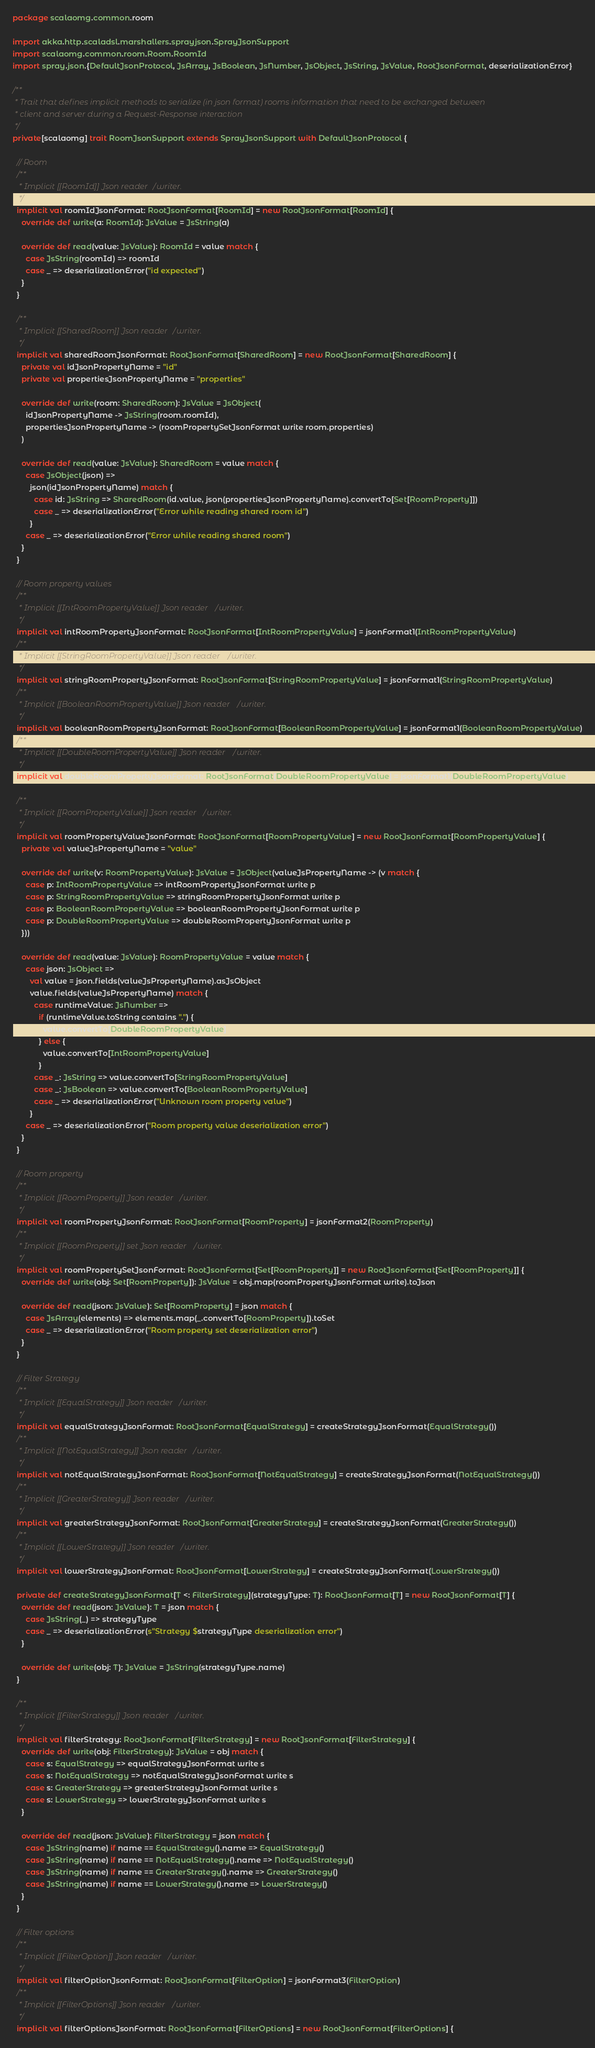Convert code to text. <code><loc_0><loc_0><loc_500><loc_500><_Scala_>package scalaomg.common.room

import akka.http.scaladsl.marshallers.sprayjson.SprayJsonSupport
import scalaomg.common.room.Room.RoomId
import spray.json.{DefaultJsonProtocol, JsArray, JsBoolean, JsNumber, JsObject, JsString, JsValue, RootJsonFormat, deserializationError}

/**
 * Trait that defines implicit methods to serialize (in json format) rooms information that need to be exchanged between
 * client and server during a Request-Response interaction
 */
private[scalaomg] trait RoomJsonSupport extends SprayJsonSupport with DefaultJsonProtocol {

  // Room
  /**
   * Implicit [[RoomId]] Json reader/writer.
   */
  implicit val roomIdJsonFormat: RootJsonFormat[RoomId] = new RootJsonFormat[RoomId] {
    override def write(a: RoomId): JsValue = JsString(a)

    override def read(value: JsValue): RoomId = value match {
      case JsString(roomId) => roomId
      case _ => deserializationError("id expected")
    }
  }

  /**
   * Implicit [[SharedRoom]] Json reader/writer.
   */
  implicit val sharedRoomJsonFormat: RootJsonFormat[SharedRoom] = new RootJsonFormat[SharedRoom] {
    private val idJsonPropertyName = "id"
    private val propertiesJsonPropertyName = "properties"

    override def write(room: SharedRoom): JsValue = JsObject(
      idJsonPropertyName -> JsString(room.roomId),
      propertiesJsonPropertyName -> (roomPropertySetJsonFormat write room.properties)
    )

    override def read(value: JsValue): SharedRoom = value match {
      case JsObject(json) =>
        json(idJsonPropertyName) match {
          case id: JsString => SharedRoom(id.value, json(propertiesJsonPropertyName).convertTo[Set[RoomProperty]])
          case _ => deserializationError("Error while reading shared room id")
        }
      case _ => deserializationError("Error while reading shared room")
    }
  }

  // Room property values
  /**
   * Implicit [[IntRoomPropertyValue]] Json reader/writer.
   */
  implicit val intRoomPropertyJsonFormat: RootJsonFormat[IntRoomPropertyValue] = jsonFormat1(IntRoomPropertyValue)
  /**
   * Implicit [[StringRoomPropertyValue]] Json reader/writer.
   */
  implicit val stringRoomPropertyJsonFormat: RootJsonFormat[StringRoomPropertyValue] = jsonFormat1(StringRoomPropertyValue)
  /**
   * Implicit [[BooleanRoomPropertyValue]] Json reader/writer.
   */
  implicit val booleanRoomPropertyJsonFormat: RootJsonFormat[BooleanRoomPropertyValue] = jsonFormat1(BooleanRoomPropertyValue)
  /**
   * Implicit [[DoubleRoomPropertyValue]] Json reader/writer.
   */
  implicit val doubleRoomPropertyJsonFormat: RootJsonFormat[DoubleRoomPropertyValue] = jsonFormat1(DoubleRoomPropertyValue)

  /**
   * Implicit [[RoomPropertyValue]] Json reader/writer.
   */
  implicit val roomPropertyValueJsonFormat: RootJsonFormat[RoomPropertyValue] = new RootJsonFormat[RoomPropertyValue] {
    private val valueJsPropertyName = "value"

    override def write(v: RoomPropertyValue): JsValue = JsObject(valueJsPropertyName -> (v match {
      case p: IntRoomPropertyValue => intRoomPropertyJsonFormat write p
      case p: StringRoomPropertyValue => stringRoomPropertyJsonFormat write p
      case p: BooleanRoomPropertyValue => booleanRoomPropertyJsonFormat write p
      case p: DoubleRoomPropertyValue => doubleRoomPropertyJsonFormat write p
    }))

    override def read(value: JsValue): RoomPropertyValue = value match {
      case json: JsObject =>
        val value = json.fields(valueJsPropertyName).asJsObject
        value.fields(valueJsPropertyName) match {
          case runtimeValue: JsNumber =>
            if (runtimeValue.toString contains ".") {
              value.convertTo[DoubleRoomPropertyValue]
            } else {
              value.convertTo[IntRoomPropertyValue]
            }
          case _: JsString => value.convertTo[StringRoomPropertyValue]
          case _: JsBoolean => value.convertTo[BooleanRoomPropertyValue]
          case _ => deserializationError("Unknown room property value")
        }
      case _ => deserializationError("Room property value deserialization error")
    }
  }

  // Room property
  /**
   * Implicit [[RoomProperty]] Json reader/writer.
   */
  implicit val roomPropertyJsonFormat: RootJsonFormat[RoomProperty] = jsonFormat2(RoomProperty)
  /**
   * Implicit [[RoomProperty]] set Json reader/writer.
   */
  implicit val roomPropertySetJsonFormat: RootJsonFormat[Set[RoomProperty]] = new RootJsonFormat[Set[RoomProperty]] {
    override def write(obj: Set[RoomProperty]): JsValue = obj.map(roomPropertyJsonFormat write).toJson

    override def read(json: JsValue): Set[RoomProperty] = json match {
      case JsArray(elements) => elements.map(_.convertTo[RoomProperty]).toSet
      case _ => deserializationError("Room property set deserialization error")
    }
  }

  // Filter Strategy
  /**
   * Implicit [[EqualStrategy]] Json reader/writer.
   */
  implicit val equalStrategyJsonFormat: RootJsonFormat[EqualStrategy] = createStrategyJsonFormat(EqualStrategy())
  /**
   * Implicit [[NotEqualStrategy]] Json reader/writer.
   */
  implicit val notEqualStrategyJsonFormat: RootJsonFormat[NotEqualStrategy] = createStrategyJsonFormat(NotEqualStrategy())
  /**
   * Implicit [[GreaterStrategy]] Json reader/writer.
   */
  implicit val greaterStrategyJsonFormat: RootJsonFormat[GreaterStrategy] = createStrategyJsonFormat(GreaterStrategy())
  /**
   * Implicit [[LowerStrategy]] Json reader/writer.
   */
  implicit val lowerStrategyJsonFormat: RootJsonFormat[LowerStrategy] = createStrategyJsonFormat(LowerStrategy())

  private def createStrategyJsonFormat[T <: FilterStrategy](strategyType: T): RootJsonFormat[T] = new RootJsonFormat[T] {
    override def read(json: JsValue): T = json match {
      case JsString(_) => strategyType
      case _ => deserializationError(s"Strategy $strategyType deserialization error")
    }

    override def write(obj: T): JsValue = JsString(strategyType.name)
  }

  /**
   * Implicit [[FilterStrategy]] Json reader/writer.
   */
  implicit val filterStrategy: RootJsonFormat[FilterStrategy] = new RootJsonFormat[FilterStrategy] {
    override def write(obj: FilterStrategy): JsValue = obj match {
      case s: EqualStrategy => equalStrategyJsonFormat write s
      case s: NotEqualStrategy => notEqualStrategyJsonFormat write s
      case s: GreaterStrategy => greaterStrategyJsonFormat write s
      case s: LowerStrategy => lowerStrategyJsonFormat write s
    }

    override def read(json: JsValue): FilterStrategy = json match {
      case JsString(name) if name == EqualStrategy().name => EqualStrategy()
      case JsString(name) if name == NotEqualStrategy().name => NotEqualStrategy()
      case JsString(name) if name == GreaterStrategy().name => GreaterStrategy()
      case JsString(name) if name == LowerStrategy().name => LowerStrategy()
    }
  }

  // Filter options
  /**
   * Implicit [[FilterOption]] Json reader/writer.
   */
  implicit val filterOptionJsonFormat: RootJsonFormat[FilterOption] = jsonFormat3(FilterOption)
  /**
   * Implicit [[FilterOptions]] Json reader/writer.
   */
  implicit val filterOptionsJsonFormat: RootJsonFormat[FilterOptions] = new RootJsonFormat[FilterOptions] {</code> 